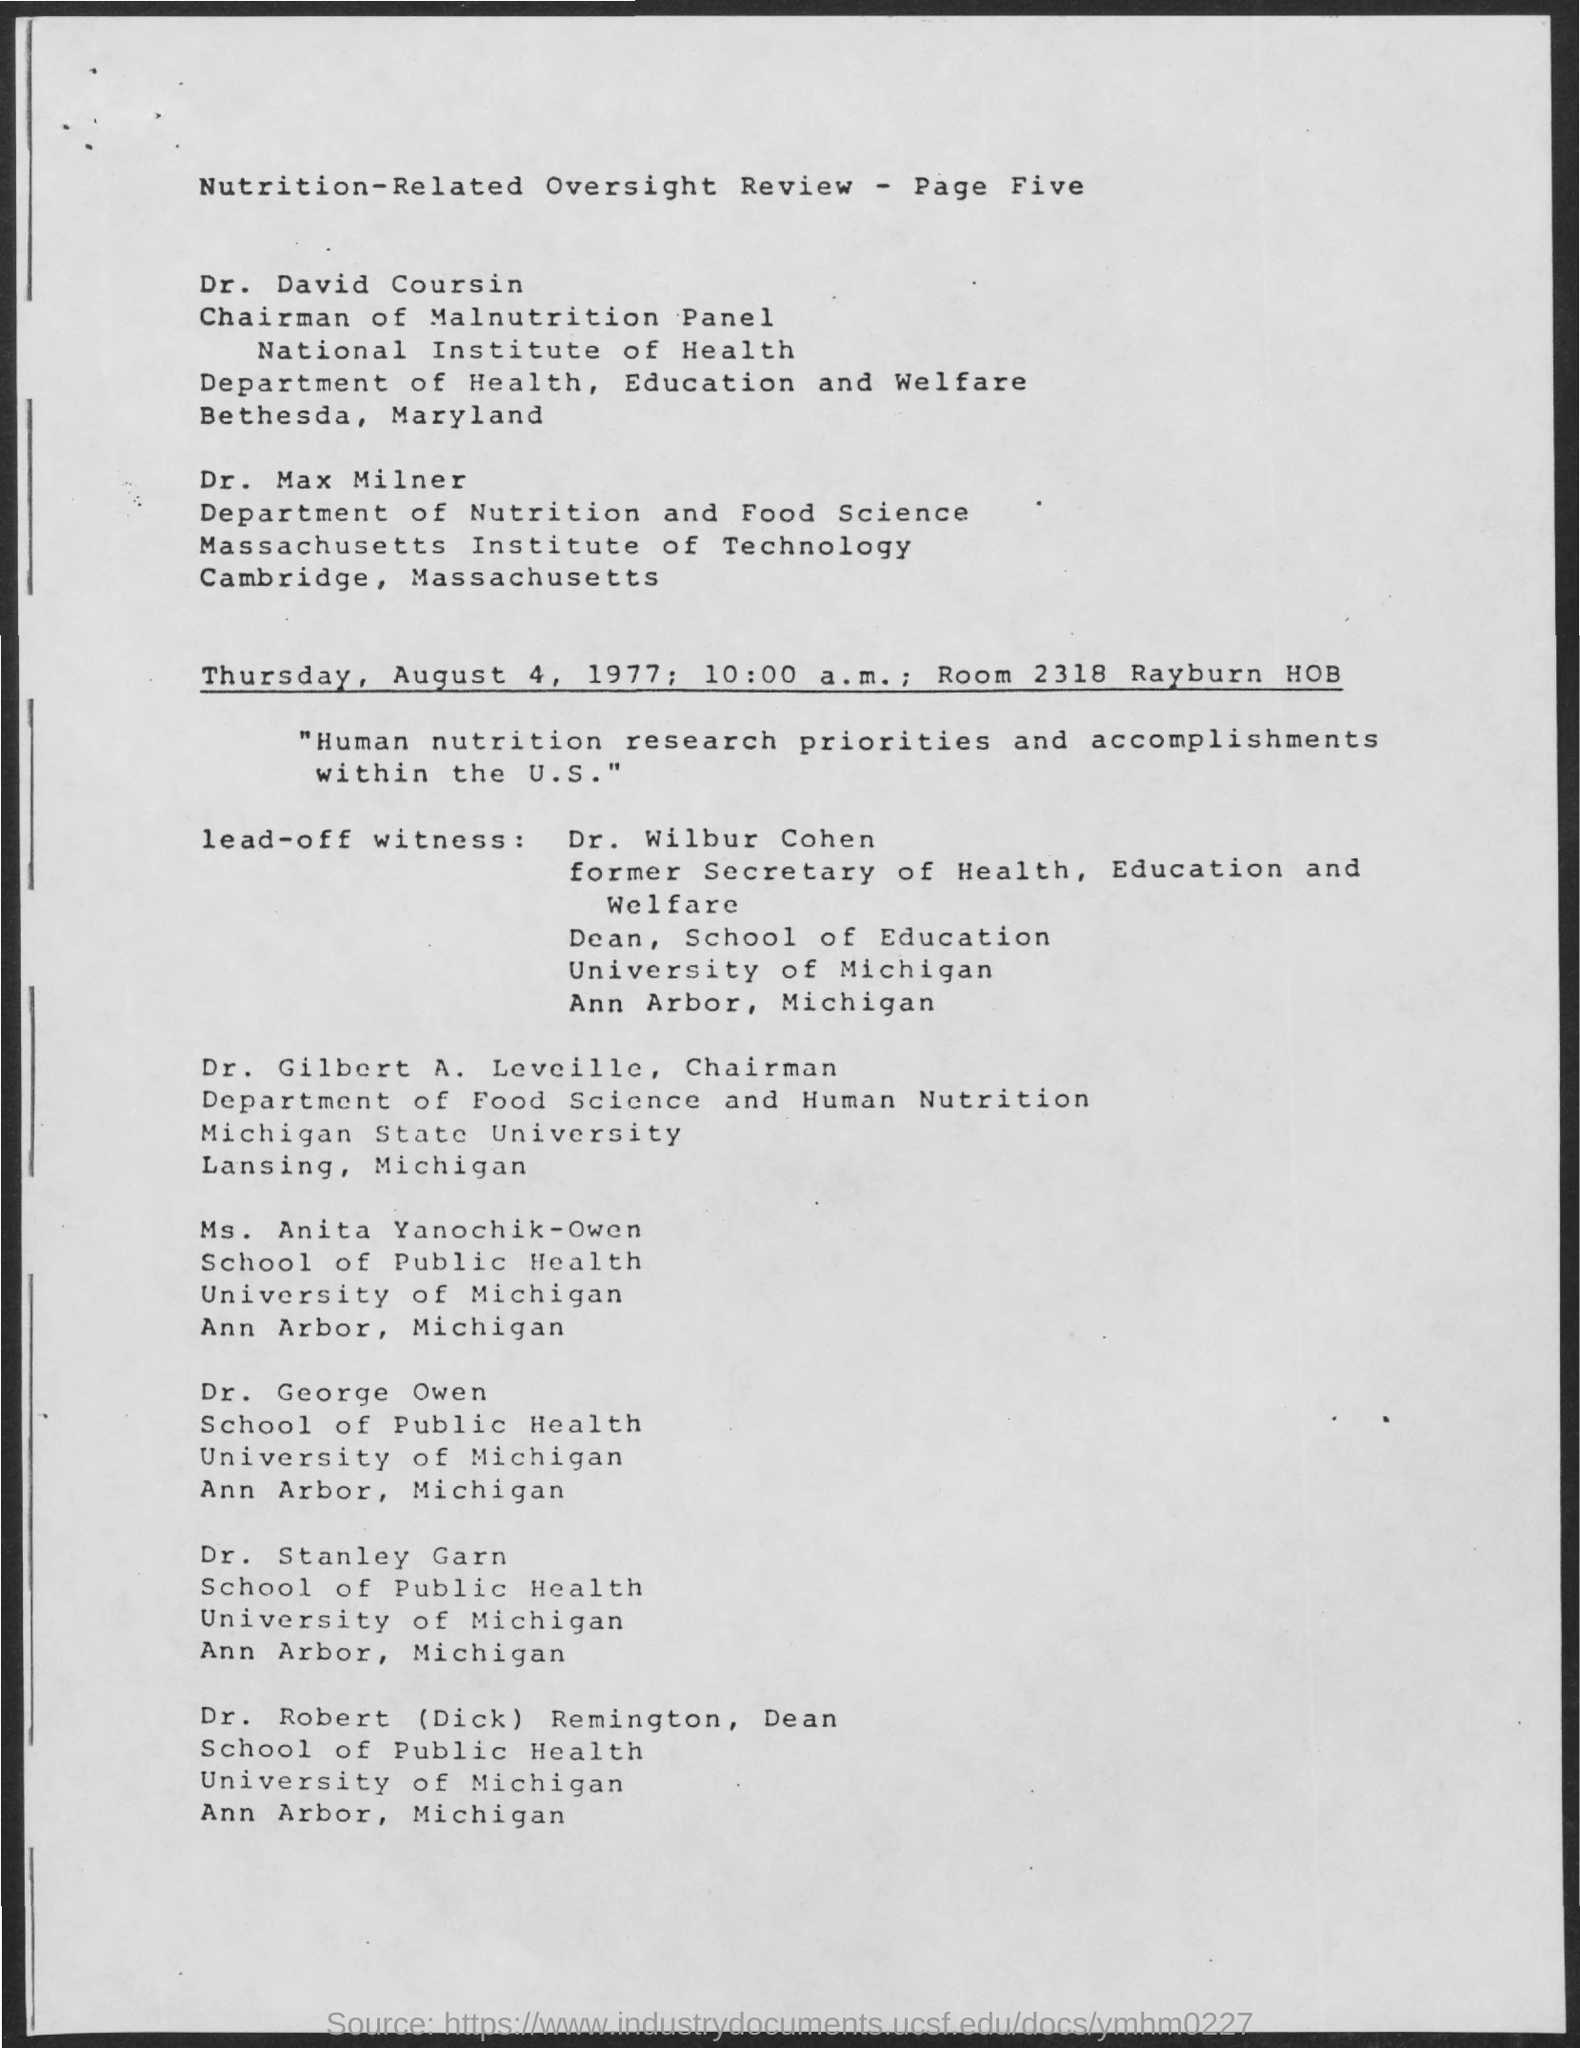What is the room number?
Offer a terse response. 2318. Massachusetts Institute of Technology is in which place?
Offer a terse response. Cambridge, massachusetts. On what date is the oversight review meet?
Ensure brevity in your answer.  Thursday, August 4, 1977. What is the time mentioned in the document?
Your answer should be compact. 10:00 a.m. What is the designation of Gilbert A. Leveille?
Ensure brevity in your answer.  Chairman. What is the designation of Robert (Dick) Remington?
Offer a very short reply. Dean. 